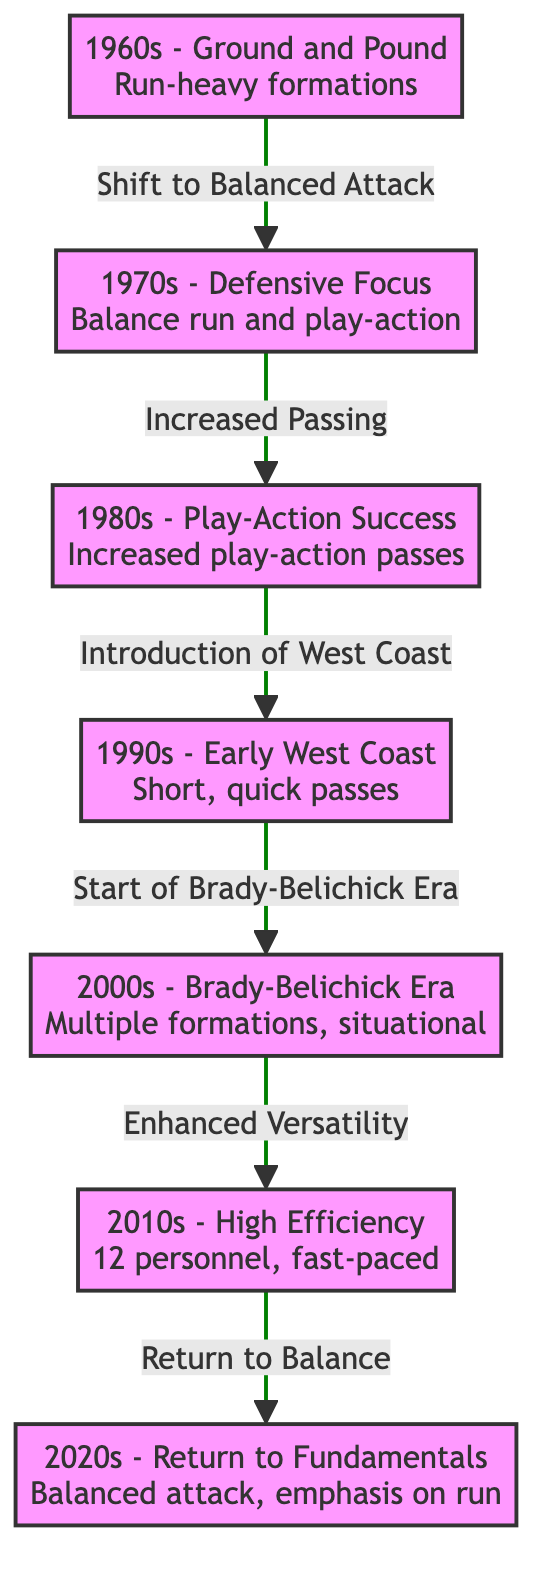What is the play-calling strategy of the 1990s? The diagram shows that the play-calling strategy for the 1990s is described as "Early West Coast" with an emphasis on "Short, quick passes." This node clearly highlights the characteristics of the play-calling during that decade.
Answer: Early West Coast What decade follows the 1980s? According to the flow depicted in the diagram, the decade that directly follows the 1980s is the 1990s. The arrows show the chronological transitions of play-calling strategies over the decades.
Answer: 1990s How many decades are represented in the diagram? By counting the distinct decade nodes presented in the diagram, we find there are a total of seven decades listed: the 1960s, 1970s, 1980s, 1990s, 2000s, 2010s, and 2020s.
Answer: Seven What strategy shift occurs from the 2000s to the 2010s? The diagram indicates that the shift from the 2000s to the 2010s is characterized by "Enhanced Versatility" in play-calling styles, which distinguishes the two decades. The transition marked by an arrow points specifically to the strategic evolution.
Answer: Enhanced Versatility Which decade is associated with a "High Efficiency" strategy? The 2010s are identified in the diagram with a strategy focused on "High Efficiency," including specific personnel formations and a fast-paced approach to the game. This is clearly shown in the corresponding node for that decade.
Answer: 2010s What is the primary focus of the 2020s? The diagram indicates that the primary focus of the 2020s is a "Return to Fundamentals," emphasizing a balanced attack with a significant focus on the run game, signified within the node of that decade.
Answer: Return to Fundamentals What strategy connects the 1970s to the 1980s? The transition between the 1970s and 1980s is characterized by "Increased Passing," as noted by the connecting arrow between the two decade nodes in the diagram. This clearly outlines the evolution of play-calling from one decade to the next.
Answer: Increased Passing How did the play-calling evolve from the 2000s to the 2010s? The diagram shows that the evolution from the 2000s to the 2010s involved a shift towards “Enhanced Versatility”, highlighting increased strategical adaptability in play-calling as indicated in the transition arrow between these decades.
Answer: Enhanced Versatility 